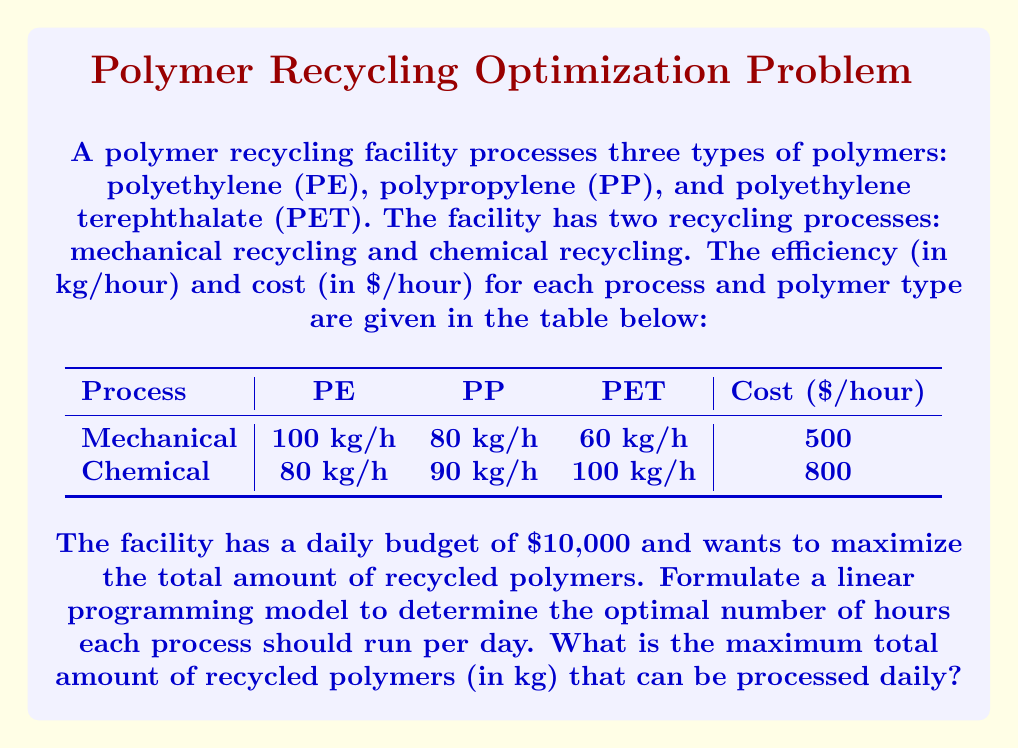Can you answer this question? To solve this problem, we need to formulate a linear programming model and then solve it. Let's break it down step by step:

1. Define decision variables:
   Let $x_1$ = number of hours for mechanical recycling
   Let $x_2$ = number of hours for chemical recycling

2. Objective function:
   We want to maximize the total amount of recycled polymers:
   $$\text{Max } Z = (100 + 80 + 60)x_1 + (80 + 90 + 100)x_2 = 240x_1 + 270x_2$$

3. Constraints:
   a. Budget constraint: The total cost should not exceed $10,000 per day
      $$500x_1 + 800x_2 \leq 10000$$
   
   b. Non-negativity constraints:
      $$x_1 \geq 0, x_2 \geq 0$$

4. Solve the linear programming problem:
   We can solve this using the graphical method or the simplex method. Let's use the graphical method for visualization.

   a. Plot the constraints:
      Budget constraint: $500x_1 + 800x_2 = 10000$
      $x_1$ intercept: (20, 0)
      $x_2$ intercept: (0, 12.5)

   b. Plot the objective function:
      $240x_1 + 270x_2 = Z$

   c. Find the optimal solution:
      The optimal solution will be at one of the corner points of the feasible region. We need to evaluate the objective function at these points:

      (0, 0): Z = 0
      (20, 0): Z = 4800
      (0, 12.5): Z = 3375
      Intersection point: Solve $500x_1 + 800x_2 = 10000$ and $x_2 = 12.5 - \frac{5}{8}x_1$
      $x_1 = 8, x_2 = 7.5$

      At (8, 7.5): Z = 240(8) + 270(7.5) = 3945

5. The optimal solution is $x_1 = 8$ hours of mechanical recycling and $x_2 = 7.5$ hours of chemical recycling.

6. Calculate the maximum total amount of recycled polymers:
   $$\text{Total} = 240(8) + 270(7.5) = 1920 + 2025 = 3945 \text{ kg}$$
Answer: The maximum total amount of recycled polymers that can be processed daily is 3945 kg. 